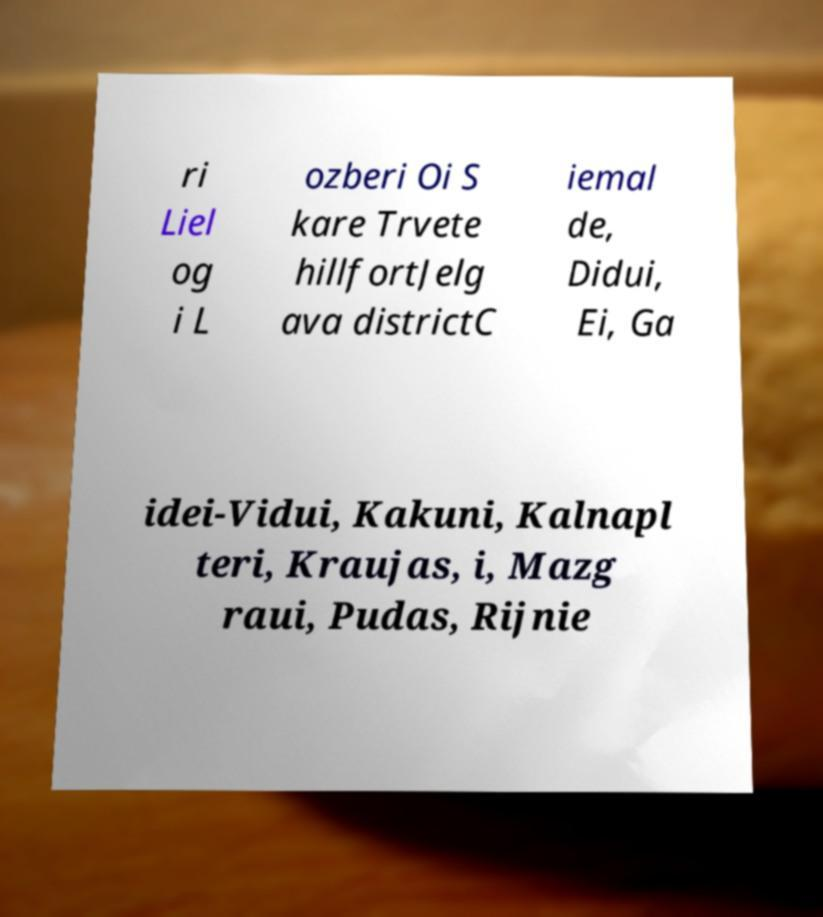There's text embedded in this image that I need extracted. Can you transcribe it verbatim? ri Liel og i L ozberi Oi S kare Trvete hillfortJelg ava districtC iemal de, Didui, Ei, Ga idei-Vidui, Kakuni, Kalnapl teri, Kraujas, i, Mazg raui, Pudas, Rijnie 